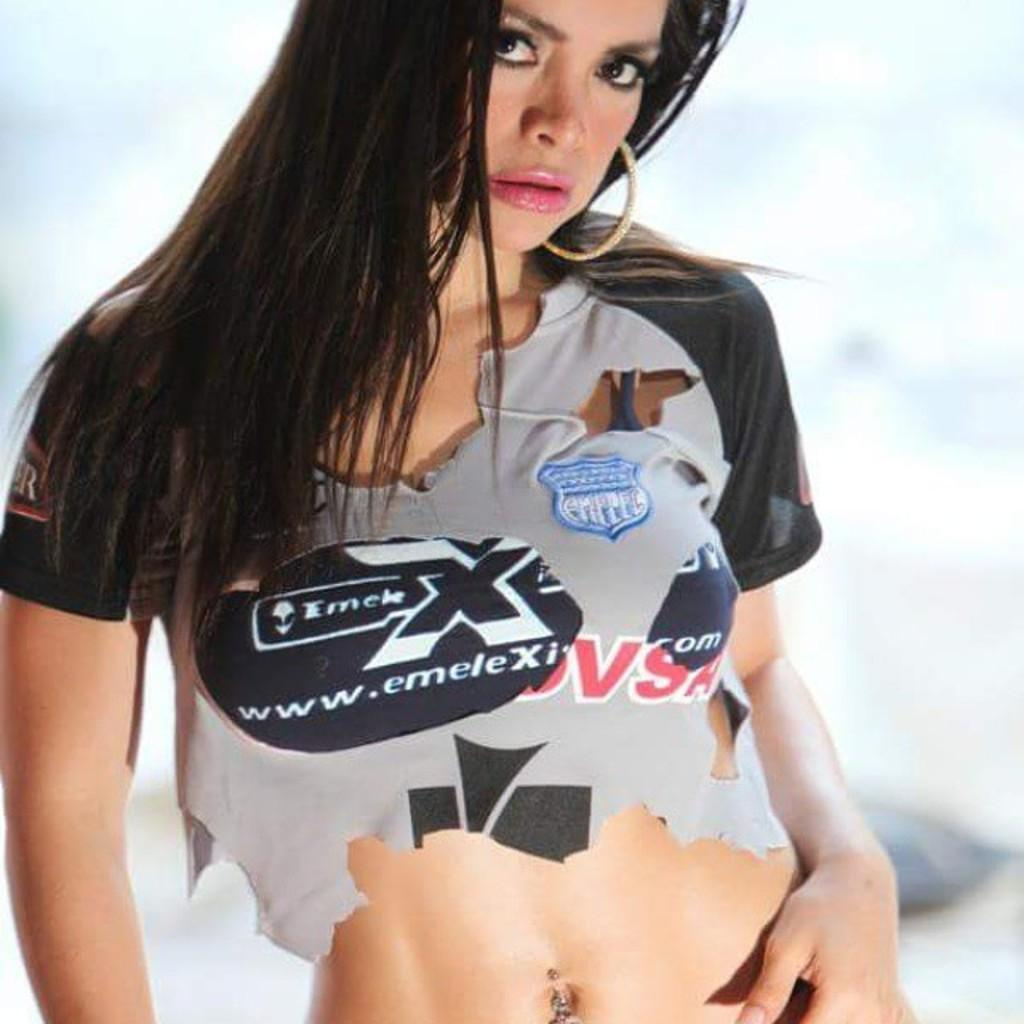<image>
Provide a brief description of the given image. A female model with an advertisement for EmeleX on her shirt 